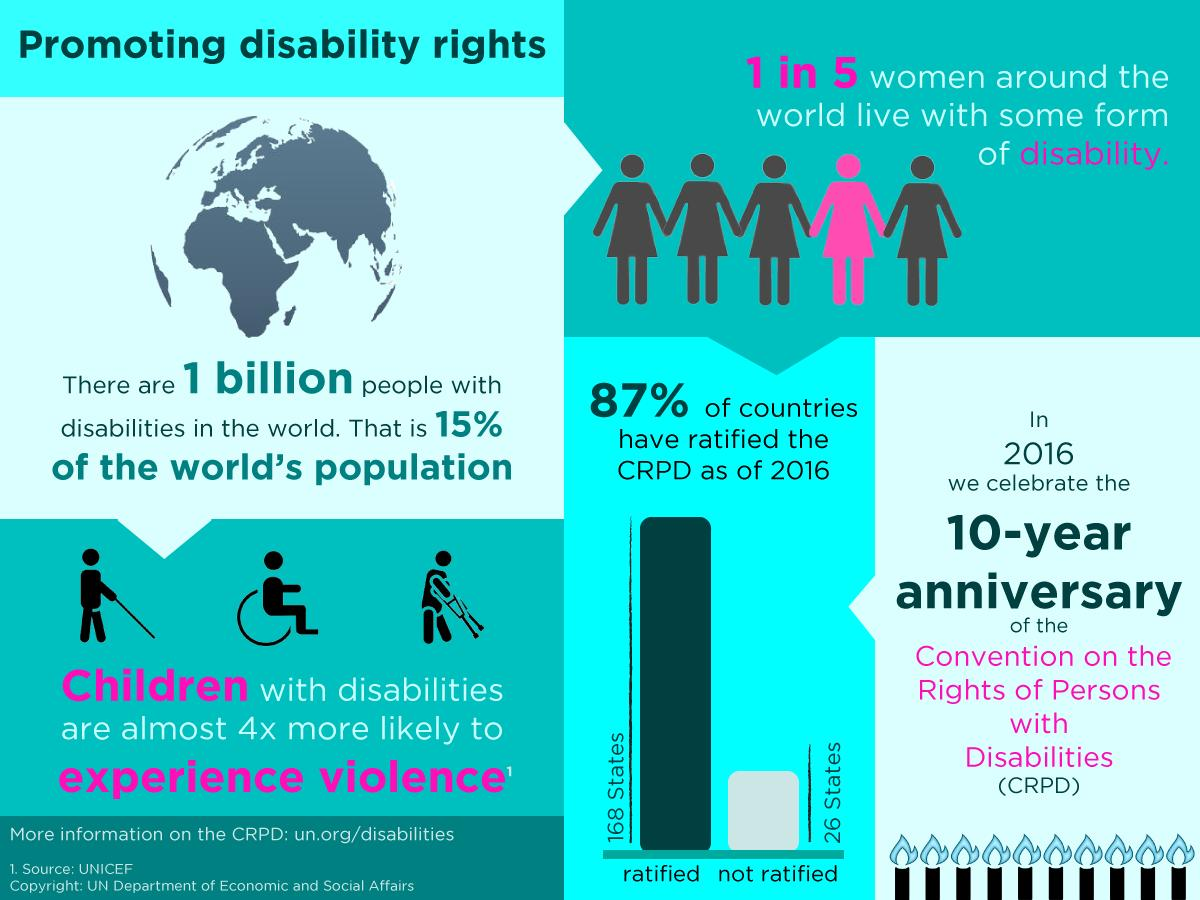Specify some key components in this picture. In 2016, 13% of countries had not yet ratified the Convention on the Prohibition of the Development, Production, Stockpiling and Use of Chemical Weapons and on Their Destruction, also known as the CPRD. 